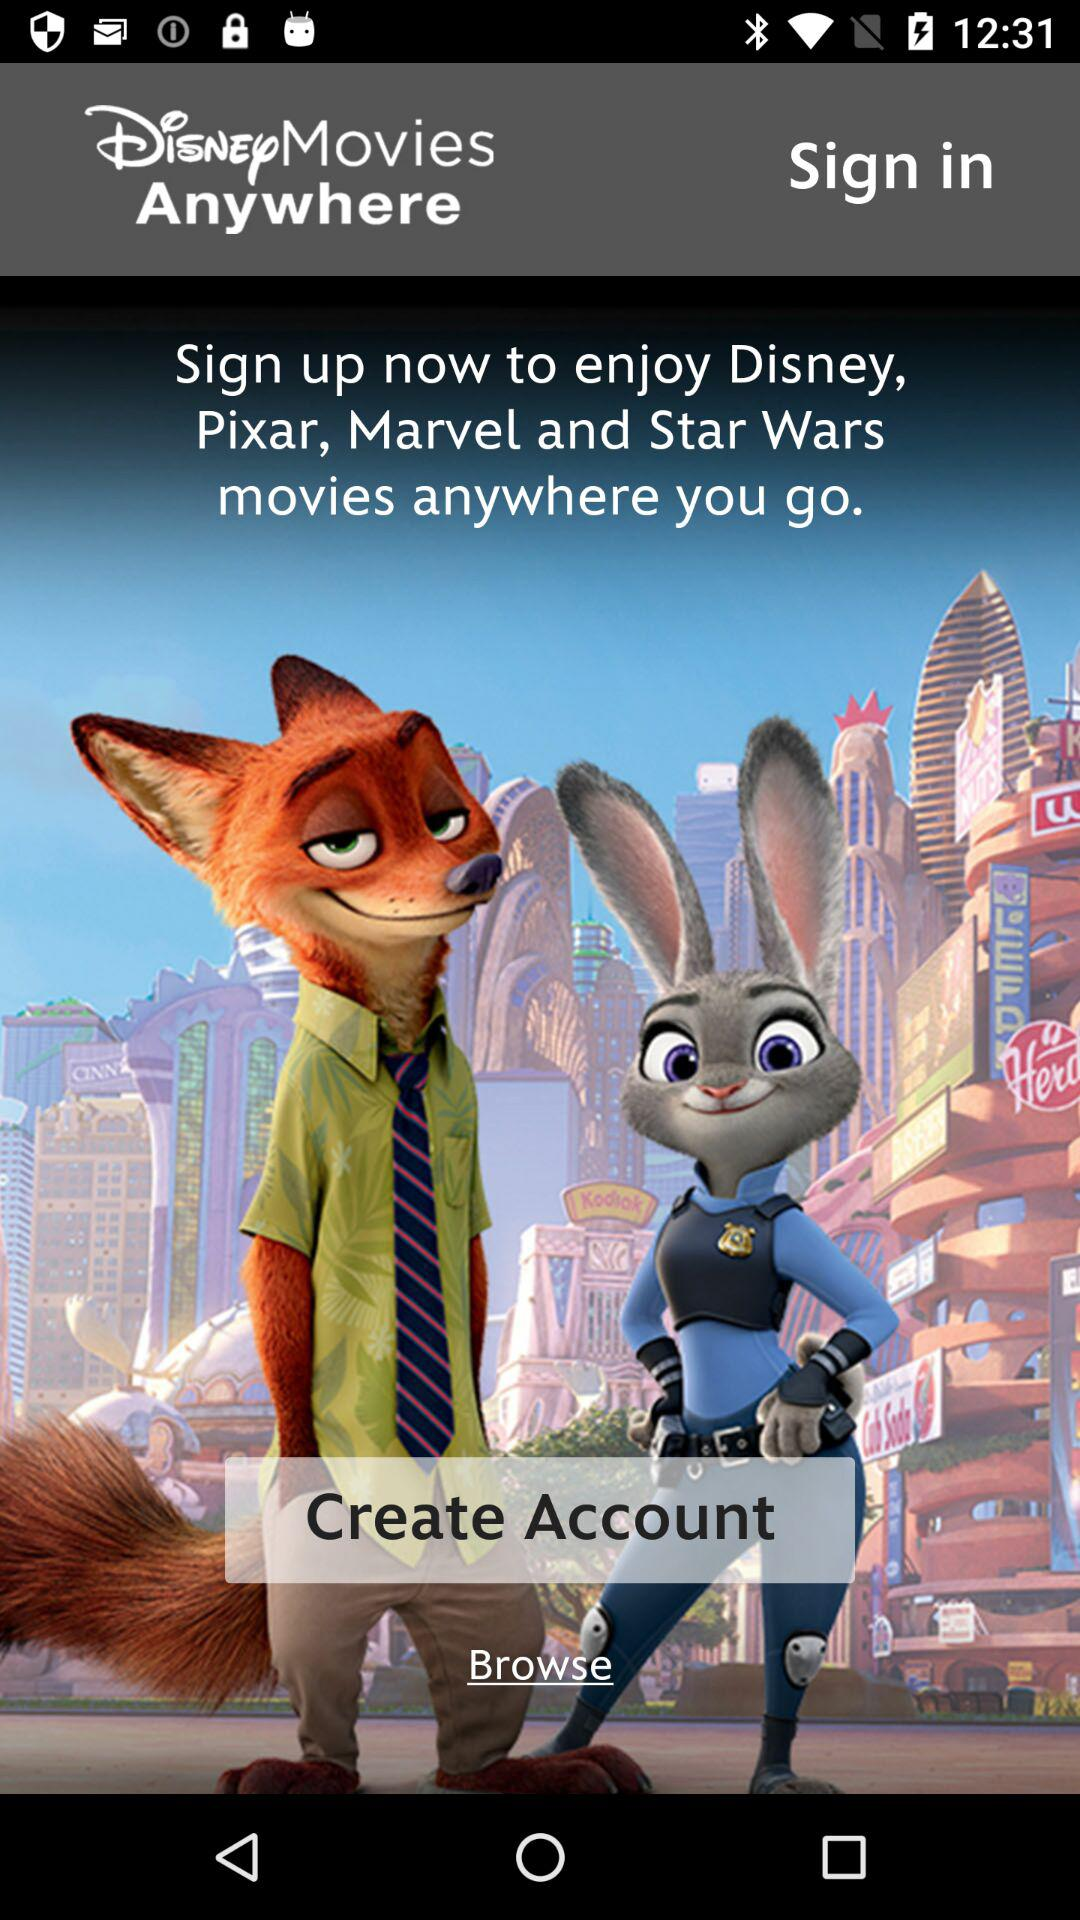What is the username?
When the provided information is insufficient, respond with <no answer>. <no answer> 